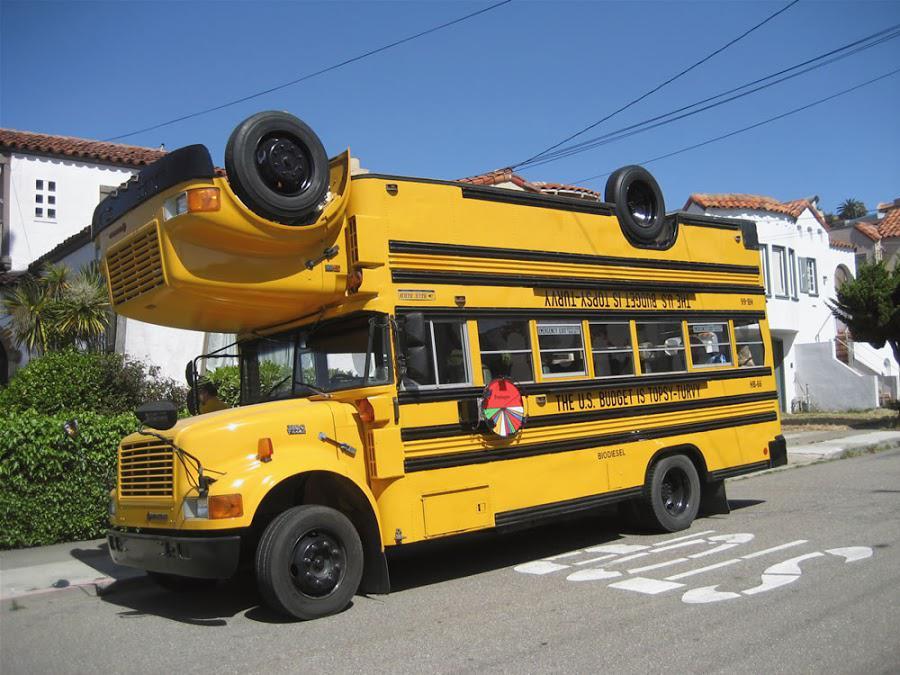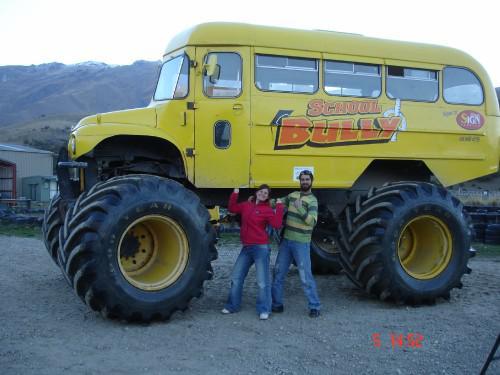The first image is the image on the left, the second image is the image on the right. For the images displayed, is the sentence "One bus has wheels on its roof." factually correct? Answer yes or no. Yes. The first image is the image on the left, the second image is the image on the right. Considering the images on both sides, is "The right image shows a sideways short bus with not more than three rectangular passenger windows, and the left image shows a bus with an inverted bus on its top." valid? Answer yes or no. Yes. 